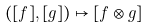Convert formula to latex. <formula><loc_0><loc_0><loc_500><loc_500>( [ f ] , [ g ] ) \mapsto [ f \otimes g ]</formula> 